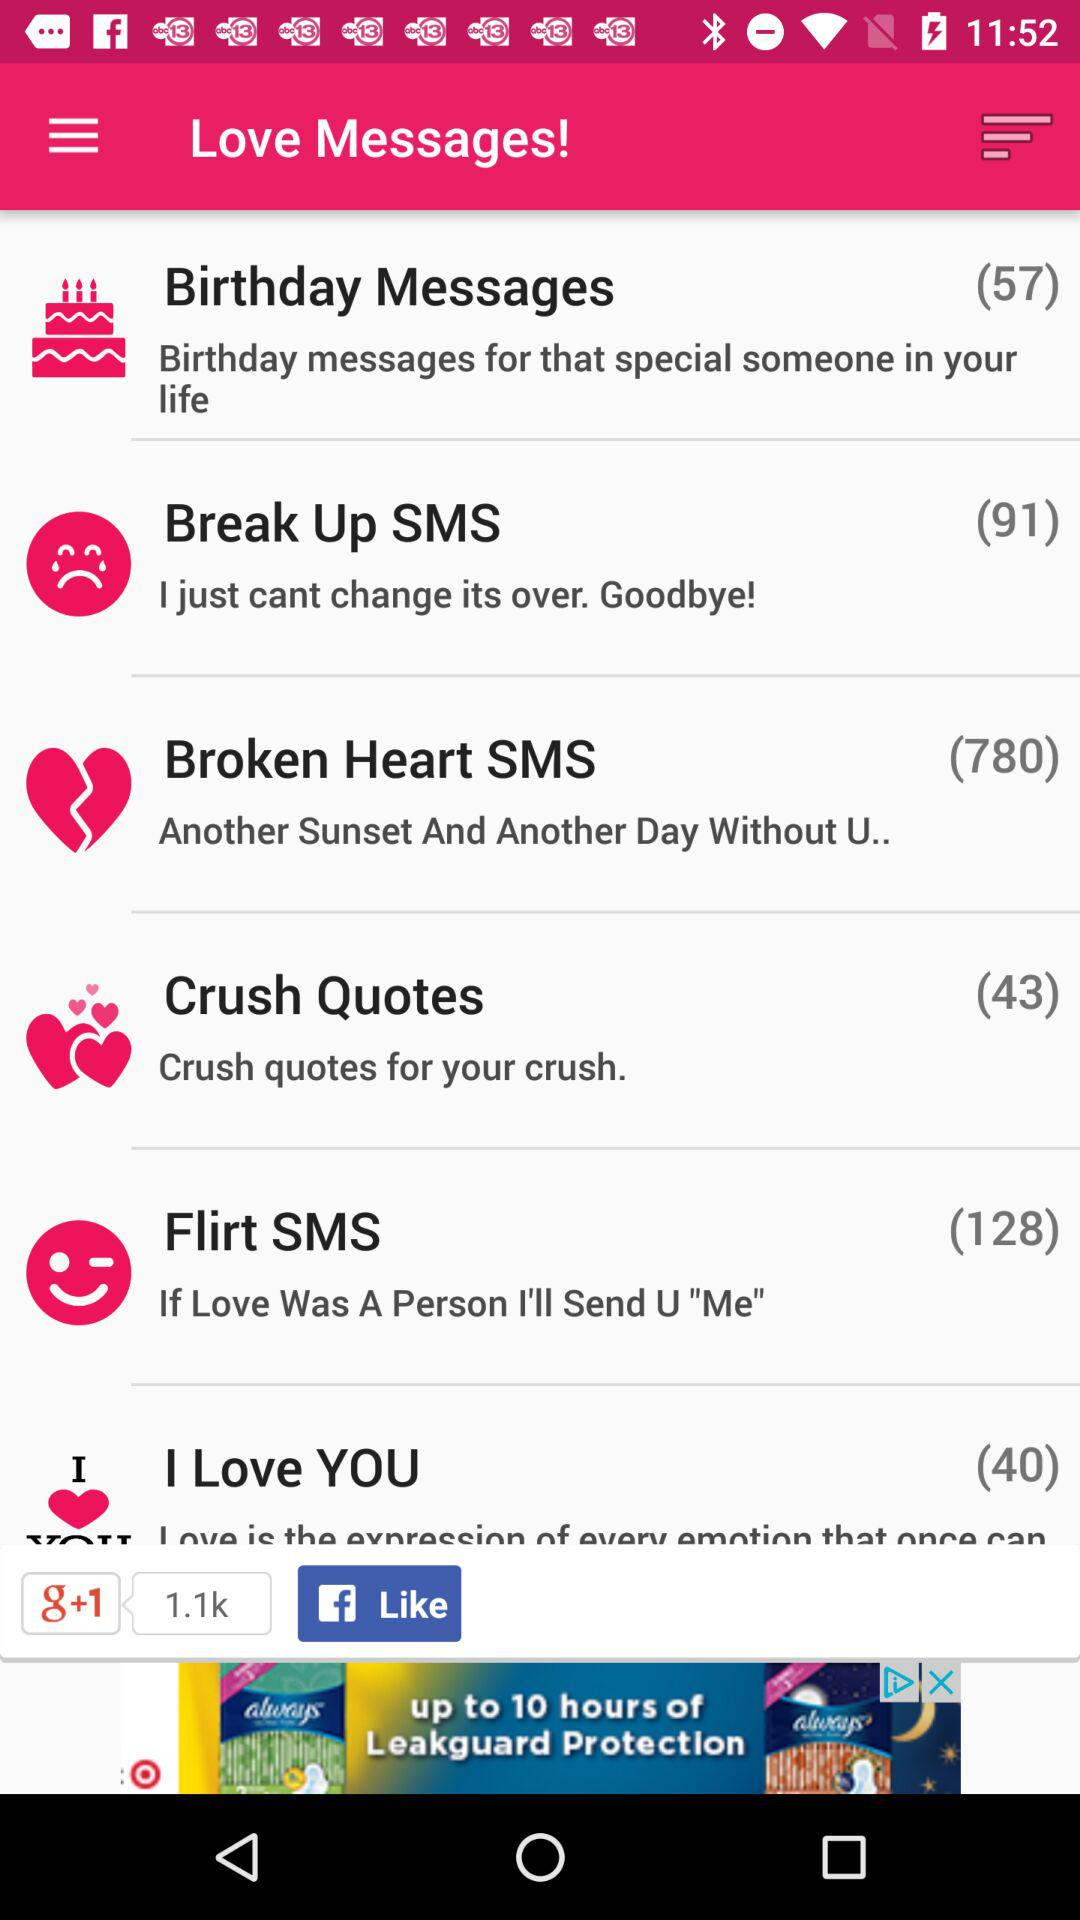How many messages are in "Birthday Messages"? There are 57 messages in "Birthday Messages". 